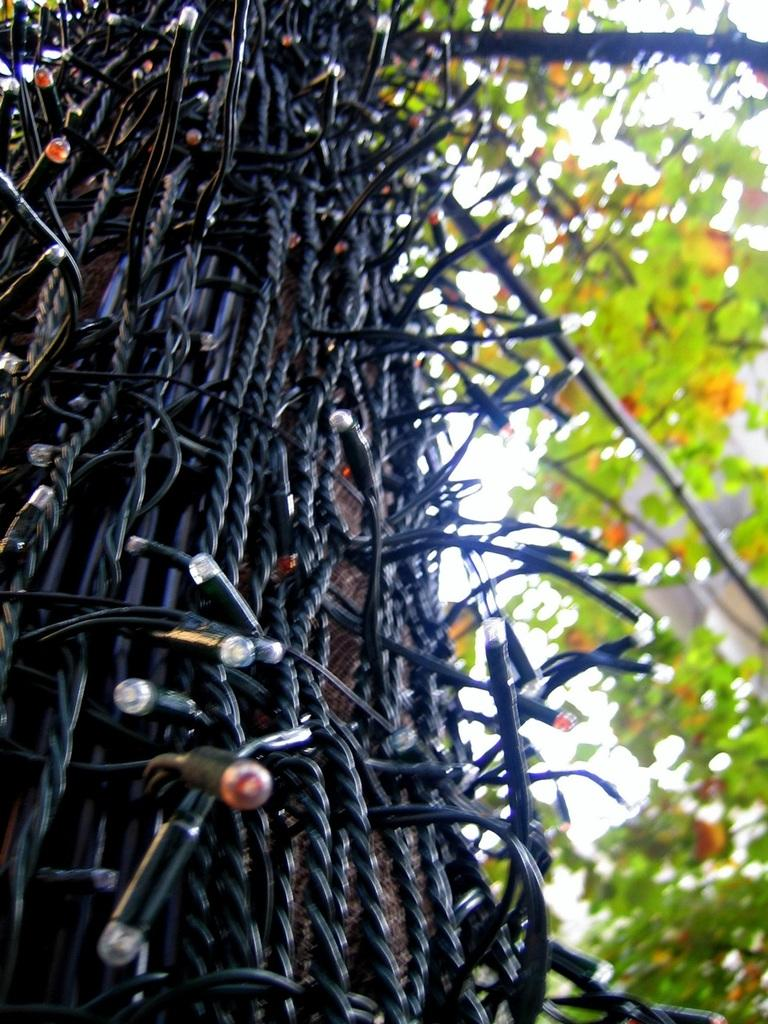What type of lighting is present in the image? There are electric lights in the image. What natural element can be seen in the image? There is a tree in the image. How does the tree attack the electric lights in the image? There is no attack or interaction between the tree and the electric lights in the image. The tree and the electric lights are separate elements in the image. 